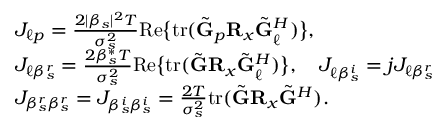<formula> <loc_0><loc_0><loc_500><loc_500>\begin{array} { r l } & { J _ { \ell p } = \frac { 2 | \beta _ { s } | ^ { 2 } T } { \sigma _ { s } ^ { 2 } } R e \left \{ t r ( \tilde { G } _ { p } R _ { x } \tilde { G } _ { \ell } ^ { H } ) \right \} , } \\ & { J _ { \ell \beta _ { s } ^ { r } } = \frac { 2 \beta _ { s } ^ { * } T } { \sigma _ { s } ^ { 2 } } R e \left \{ t r ( \tilde { G } R _ { x } \tilde { G } _ { \ell } ^ { H } ) \right \} , \quad J _ { \ell \beta _ { s } ^ { i } } = j J _ { \ell \beta _ { s } ^ { r } } } \\ & { J _ { \beta _ { s } ^ { r } \beta _ { s } ^ { r } } = J _ { \beta _ { s } ^ { i } \beta _ { s } ^ { i } } = \frac { 2 T } { \sigma _ { s } ^ { 2 } } t r ( \tilde { G } R _ { x } \tilde { G } ^ { H } ) . } \end{array}</formula> 